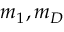Convert formula to latex. <formula><loc_0><loc_0><loc_500><loc_500>m _ { 1 } , m _ { D }</formula> 